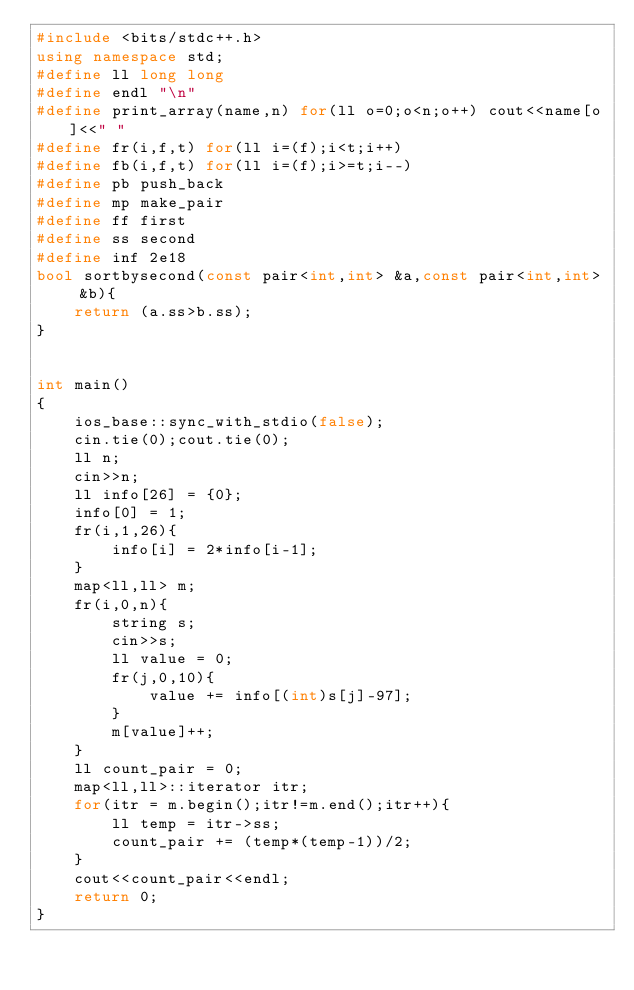<code> <loc_0><loc_0><loc_500><loc_500><_C++_>#include <bits/stdc++.h>
using namespace std;
#define ll long long
#define endl "\n"
#define print_array(name,n) for(ll o=0;o<n;o++) cout<<name[o]<<" "
#define fr(i,f,t) for(ll i=(f);i<t;i++)
#define fb(i,f,t) for(ll i=(f);i>=t;i--)
#define pb push_back
#define mp make_pair
#define ff first
#define ss second
#define inf 2e18
bool sortbysecond(const pair<int,int> &a,const pair<int,int> &b){
	return (a.ss>b.ss);
}


int main()
{
    ios_base::sync_with_stdio(false);
    cin.tie(0);cout.tie(0);
    ll n;
    cin>>n;
    ll info[26] = {0};
    info[0] = 1;
    fr(i,1,26){
    	info[i] = 2*info[i-1];
    }
    map<ll,ll> m;
    fr(i,0,n){
    	string s;
    	cin>>s;
    	ll value = 0;
    	fr(j,0,10){
    		value += info[(int)s[j]-97];
    	}
    	m[value]++;
    }
    ll count_pair = 0;
    map<ll,ll>::iterator itr;
    for(itr = m.begin();itr!=m.end();itr++){
    	ll temp = itr->ss;
    	count_pair += (temp*(temp-1))/2;
    }
    cout<<count_pair<<endl;
    return 0;
}
</code> 